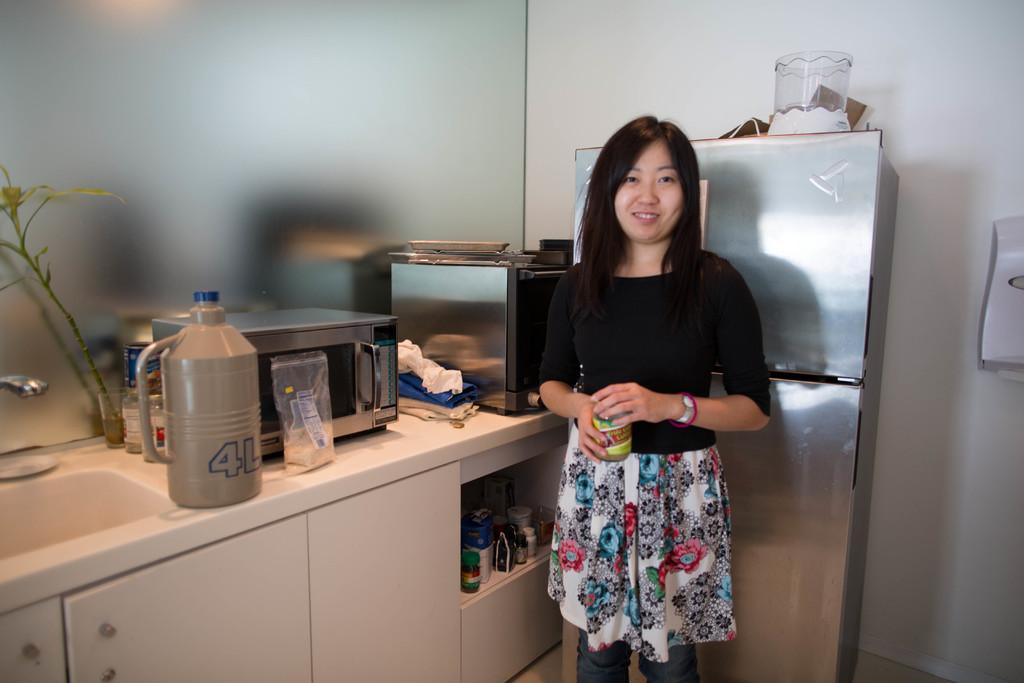What does the bottle on the counter say?
Your answer should be very brief. 4l. 